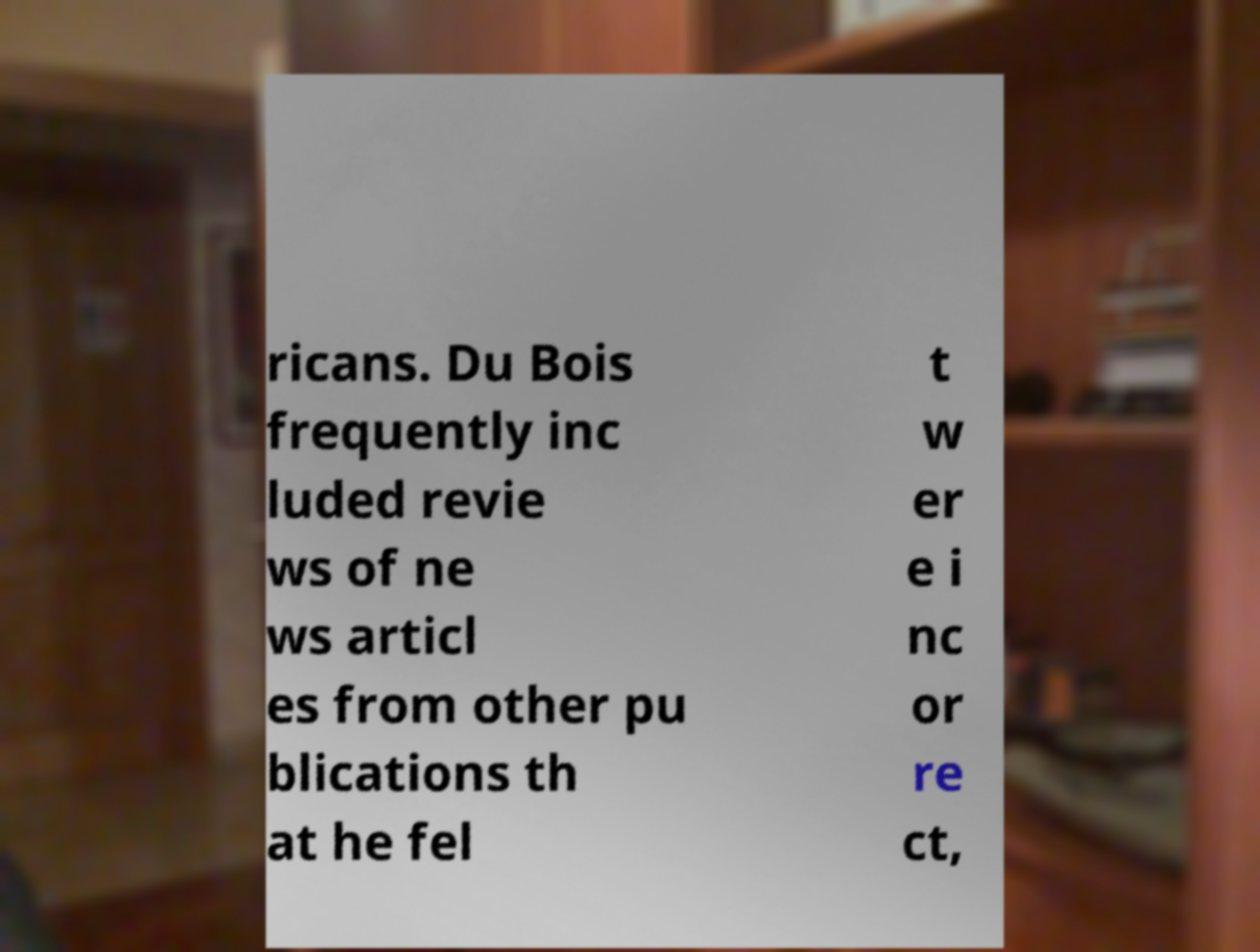Can you read and provide the text displayed in the image?This photo seems to have some interesting text. Can you extract and type it out for me? ricans. Du Bois frequently inc luded revie ws of ne ws articl es from other pu blications th at he fel t w er e i nc or re ct, 